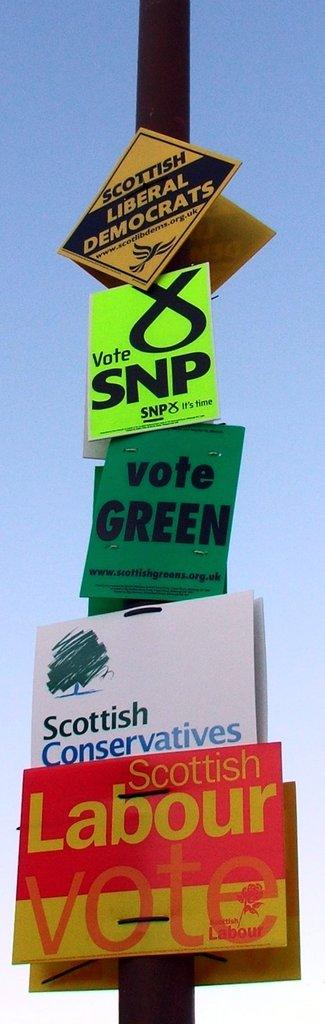Provide a one-sentence caption for the provided image. An assortment of political posters are attached to a pole, including signs for the Scottish Labour Vote, Scottish Conservatives, and the SNP. 